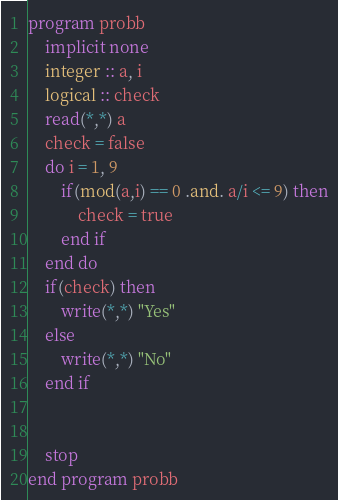<code> <loc_0><loc_0><loc_500><loc_500><_FORTRAN_>program probb
	implicit none
    integer :: a, i
    logical :: check
    read(*,*) a
    check = false
    do i = 1, 9
    	if(mod(a,i) == 0 .and. a/i <= 9) then
        	check = true
        end if
   	end do
    if(check) then
    	write(*,*) "Yes"
    else
    	write(*,*) "No"
    end if
    
    
    stop
end program probb
</code> 